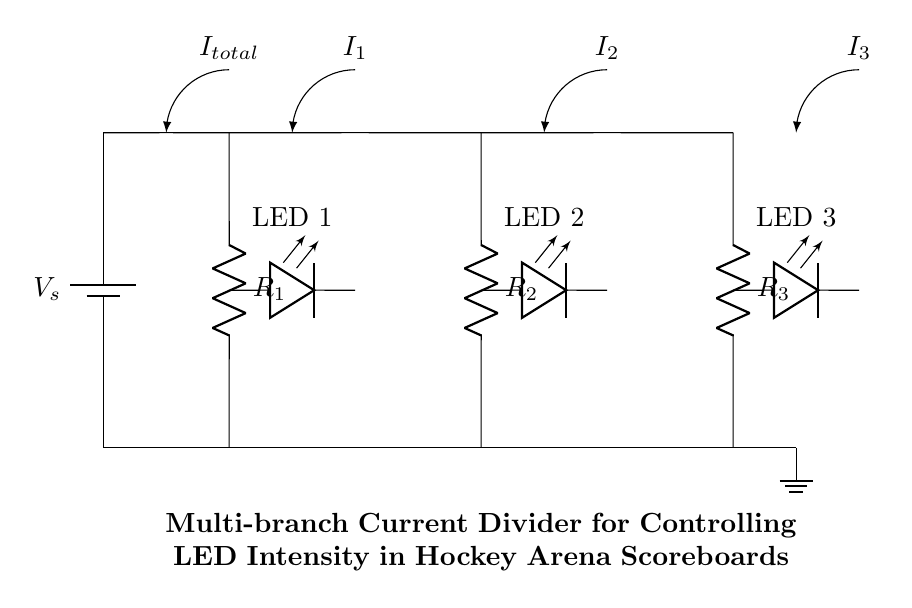What is the total current entering the circuit? The total current entering the circuit is labeled as I total, which indicates the sum of all branch currents. The labeling is directly visible in the circuit diagram.
Answer: I total What are the series resistances in this circuit? The series resistances in the circuit are labeled as R1, R2, and R3. They are clearly indicated in the diagram connected in separate branches of the current divider.
Answer: R1, R2, R3 What type of components are used in each branch? Each branch contains a resistor and an LED. The resistors R1, R2, and R3 are connected in series with LEDs labeled LED 1, LED 2, and LED 3, respectively. This is observable in the arrangement of the circuit.
Answer: Resistor and LED How does current behavior change as it divides among branches? The current I total splits into I 1, I 2, and I 3 as it flows through each branch according to the resistance values; lower resistances allow more current to flow through their branches. This behavior is a fundamental principle of current dividers.
Answer: It divides based on resistance What determines the brightness of the LEDs in this circuit? The brightness of the LEDs is determined by the current flowing through each respective branch, where a higher current results in greater brightness. The relationship is rooted in the current divider principle and the specific resistances used in each branch.
Answer: Current through each branch Which LED is positioned between R1 and R2? The LED positioned between R1 and R2 is LED 1, as indicated by its connection directly after R1 and before the ground connection. The arrangement of components clarifies which LED corresponds to which resistor.
Answer: LED 1 